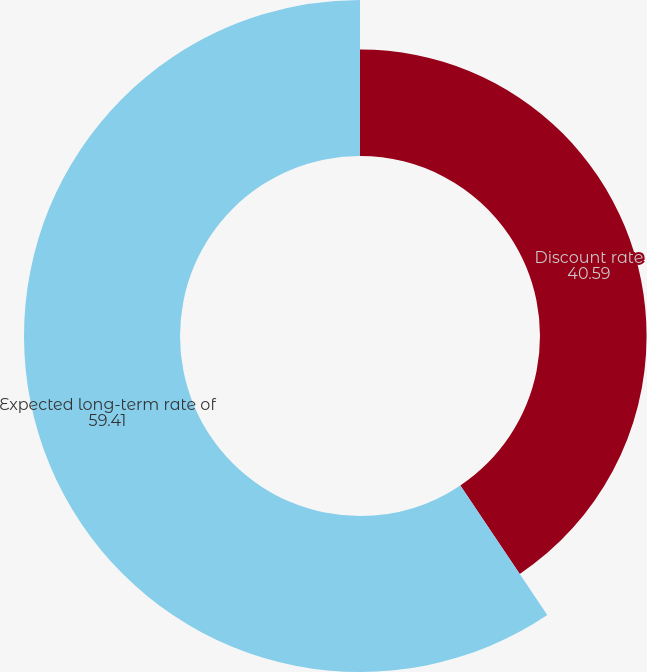<chart> <loc_0><loc_0><loc_500><loc_500><pie_chart><fcel>Discount rate<fcel>Expected long-term rate of<nl><fcel>40.59%<fcel>59.41%<nl></chart> 